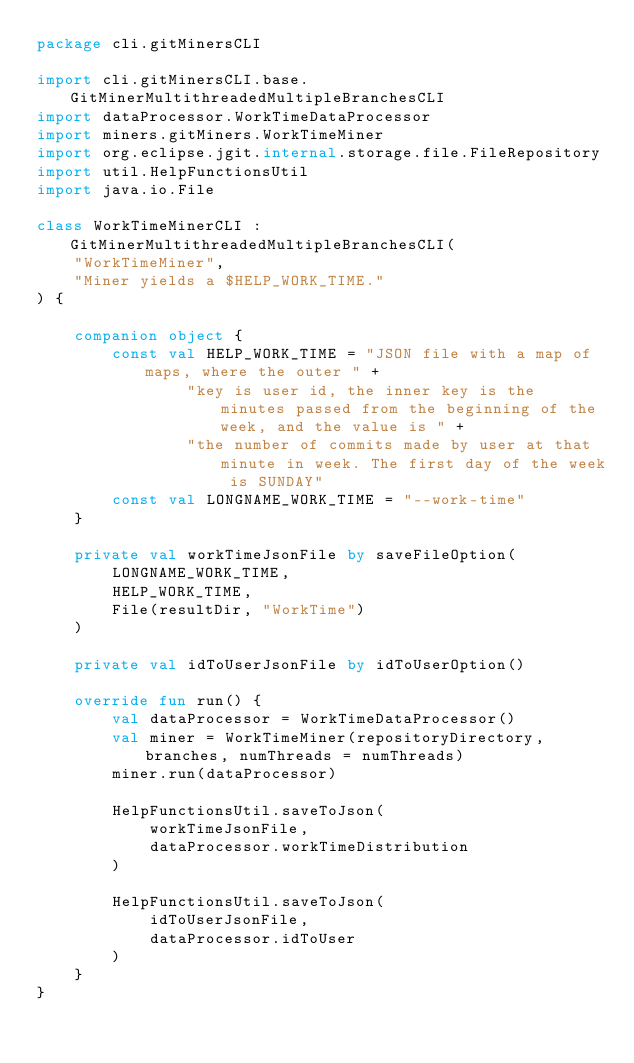Convert code to text. <code><loc_0><loc_0><loc_500><loc_500><_Kotlin_>package cli.gitMinersCLI

import cli.gitMinersCLI.base.GitMinerMultithreadedMultipleBranchesCLI
import dataProcessor.WorkTimeDataProcessor
import miners.gitMiners.WorkTimeMiner
import org.eclipse.jgit.internal.storage.file.FileRepository
import util.HelpFunctionsUtil
import java.io.File

class WorkTimeMinerCLI : GitMinerMultithreadedMultipleBranchesCLI(
    "WorkTimeMiner",
    "Miner yields a $HELP_WORK_TIME."
) {

    companion object {
        const val HELP_WORK_TIME = "JSON file with a map of maps, where the outer " +
                "key is user id, the inner key is the minutes passed from the beginning of the week, and the value is " +
                "the number of commits made by user at that minute in week. The first day of the week is SUNDAY"
        const val LONGNAME_WORK_TIME = "--work-time"
    }

    private val workTimeJsonFile by saveFileOption(
        LONGNAME_WORK_TIME,
        HELP_WORK_TIME,
        File(resultDir, "WorkTime")
    )

    private val idToUserJsonFile by idToUserOption()

    override fun run() {
        val dataProcessor = WorkTimeDataProcessor()
        val miner = WorkTimeMiner(repositoryDirectory, branches, numThreads = numThreads)
        miner.run(dataProcessor)

        HelpFunctionsUtil.saveToJson(
            workTimeJsonFile,
            dataProcessor.workTimeDistribution
        )

        HelpFunctionsUtil.saveToJson(
            idToUserJsonFile,
            dataProcessor.idToUser
        )
    }
}</code> 